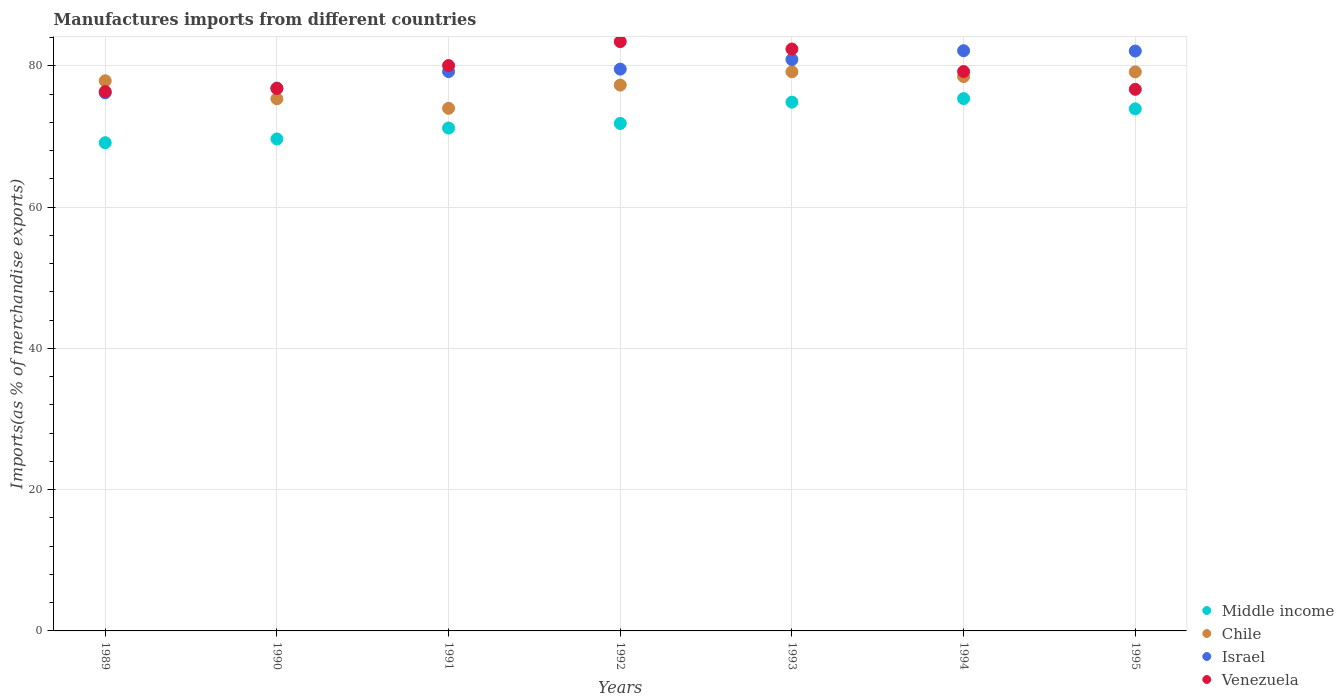How many different coloured dotlines are there?
Provide a succinct answer. 4. Is the number of dotlines equal to the number of legend labels?
Give a very brief answer. Yes. What is the percentage of imports to different countries in Israel in 1995?
Your answer should be compact. 82.09. Across all years, what is the maximum percentage of imports to different countries in Venezuela?
Offer a terse response. 83.42. Across all years, what is the minimum percentage of imports to different countries in Israel?
Your answer should be very brief. 76.18. In which year was the percentage of imports to different countries in Israel minimum?
Your response must be concise. 1989. What is the total percentage of imports to different countries in Chile in the graph?
Offer a terse response. 541.24. What is the difference between the percentage of imports to different countries in Chile in 1992 and that in 1995?
Your answer should be compact. -1.87. What is the difference between the percentage of imports to different countries in Israel in 1992 and the percentage of imports to different countries in Venezuela in 1994?
Your response must be concise. 0.34. What is the average percentage of imports to different countries in Middle income per year?
Make the answer very short. 72.27. In the year 1992, what is the difference between the percentage of imports to different countries in Middle income and percentage of imports to different countries in Venezuela?
Give a very brief answer. -11.58. What is the ratio of the percentage of imports to different countries in Middle income in 1990 to that in 1992?
Offer a terse response. 0.97. Is the percentage of imports to different countries in Israel in 1991 less than that in 1994?
Give a very brief answer. Yes. Is the difference between the percentage of imports to different countries in Middle income in 1993 and 1995 greater than the difference between the percentage of imports to different countries in Venezuela in 1993 and 1995?
Offer a very short reply. No. What is the difference between the highest and the second highest percentage of imports to different countries in Middle income?
Your answer should be very brief. 0.5. What is the difference between the highest and the lowest percentage of imports to different countries in Chile?
Offer a terse response. 5.17. Is it the case that in every year, the sum of the percentage of imports to different countries in Venezuela and percentage of imports to different countries in Israel  is greater than the percentage of imports to different countries in Chile?
Your answer should be compact. Yes. Does the percentage of imports to different countries in Venezuela monotonically increase over the years?
Make the answer very short. No. Is the percentage of imports to different countries in Israel strictly less than the percentage of imports to different countries in Chile over the years?
Ensure brevity in your answer.  No. How many years are there in the graph?
Offer a very short reply. 7. Does the graph contain any zero values?
Ensure brevity in your answer.  No. How are the legend labels stacked?
Your answer should be compact. Vertical. What is the title of the graph?
Your response must be concise. Manufactures imports from different countries. Does "Equatorial Guinea" appear as one of the legend labels in the graph?
Provide a succinct answer. No. What is the label or title of the X-axis?
Provide a succinct answer. Years. What is the label or title of the Y-axis?
Offer a very short reply. Imports(as % of merchandise exports). What is the Imports(as % of merchandise exports) of Middle income in 1989?
Your answer should be very brief. 69.11. What is the Imports(as % of merchandise exports) in Chile in 1989?
Offer a terse response. 77.88. What is the Imports(as % of merchandise exports) of Israel in 1989?
Ensure brevity in your answer.  76.18. What is the Imports(as % of merchandise exports) in Venezuela in 1989?
Keep it short and to the point. 76.35. What is the Imports(as % of merchandise exports) in Middle income in 1990?
Your answer should be very brief. 69.64. What is the Imports(as % of merchandise exports) of Chile in 1990?
Keep it short and to the point. 75.33. What is the Imports(as % of merchandise exports) in Israel in 1990?
Give a very brief answer. 76.84. What is the Imports(as % of merchandise exports) in Venezuela in 1990?
Give a very brief answer. 76.79. What is the Imports(as % of merchandise exports) of Middle income in 1991?
Give a very brief answer. 71.19. What is the Imports(as % of merchandise exports) in Chile in 1991?
Your answer should be very brief. 73.98. What is the Imports(as % of merchandise exports) in Israel in 1991?
Offer a very short reply. 79.18. What is the Imports(as % of merchandise exports) of Venezuela in 1991?
Your answer should be very brief. 80.03. What is the Imports(as % of merchandise exports) in Middle income in 1992?
Keep it short and to the point. 71.84. What is the Imports(as % of merchandise exports) of Chile in 1992?
Offer a terse response. 77.27. What is the Imports(as % of merchandise exports) of Israel in 1992?
Provide a short and direct response. 79.53. What is the Imports(as % of merchandise exports) of Venezuela in 1992?
Keep it short and to the point. 83.42. What is the Imports(as % of merchandise exports) of Middle income in 1993?
Offer a very short reply. 74.86. What is the Imports(as % of merchandise exports) of Chile in 1993?
Your answer should be very brief. 79.16. What is the Imports(as % of merchandise exports) in Israel in 1993?
Your answer should be very brief. 80.89. What is the Imports(as % of merchandise exports) in Venezuela in 1993?
Your answer should be compact. 82.38. What is the Imports(as % of merchandise exports) of Middle income in 1994?
Make the answer very short. 75.36. What is the Imports(as % of merchandise exports) of Chile in 1994?
Give a very brief answer. 78.48. What is the Imports(as % of merchandise exports) in Israel in 1994?
Make the answer very short. 82.14. What is the Imports(as % of merchandise exports) of Venezuela in 1994?
Make the answer very short. 79.19. What is the Imports(as % of merchandise exports) of Middle income in 1995?
Make the answer very short. 73.91. What is the Imports(as % of merchandise exports) in Chile in 1995?
Your response must be concise. 79.14. What is the Imports(as % of merchandise exports) of Israel in 1995?
Your answer should be very brief. 82.09. What is the Imports(as % of merchandise exports) in Venezuela in 1995?
Your response must be concise. 76.67. Across all years, what is the maximum Imports(as % of merchandise exports) in Middle income?
Make the answer very short. 75.36. Across all years, what is the maximum Imports(as % of merchandise exports) in Chile?
Make the answer very short. 79.16. Across all years, what is the maximum Imports(as % of merchandise exports) in Israel?
Offer a very short reply. 82.14. Across all years, what is the maximum Imports(as % of merchandise exports) in Venezuela?
Your answer should be very brief. 83.42. Across all years, what is the minimum Imports(as % of merchandise exports) of Middle income?
Provide a succinct answer. 69.11. Across all years, what is the minimum Imports(as % of merchandise exports) of Chile?
Your answer should be very brief. 73.98. Across all years, what is the minimum Imports(as % of merchandise exports) in Israel?
Offer a terse response. 76.18. Across all years, what is the minimum Imports(as % of merchandise exports) in Venezuela?
Offer a terse response. 76.35. What is the total Imports(as % of merchandise exports) in Middle income in the graph?
Keep it short and to the point. 505.9. What is the total Imports(as % of merchandise exports) of Chile in the graph?
Keep it short and to the point. 541.24. What is the total Imports(as % of merchandise exports) in Israel in the graph?
Offer a very short reply. 556.84. What is the total Imports(as % of merchandise exports) in Venezuela in the graph?
Keep it short and to the point. 554.83. What is the difference between the Imports(as % of merchandise exports) in Middle income in 1989 and that in 1990?
Ensure brevity in your answer.  -0.53. What is the difference between the Imports(as % of merchandise exports) of Chile in 1989 and that in 1990?
Provide a succinct answer. 2.54. What is the difference between the Imports(as % of merchandise exports) in Israel in 1989 and that in 1990?
Make the answer very short. -0.67. What is the difference between the Imports(as % of merchandise exports) of Venezuela in 1989 and that in 1990?
Provide a short and direct response. -0.44. What is the difference between the Imports(as % of merchandise exports) of Middle income in 1989 and that in 1991?
Give a very brief answer. -2.07. What is the difference between the Imports(as % of merchandise exports) of Chile in 1989 and that in 1991?
Make the answer very short. 3.89. What is the difference between the Imports(as % of merchandise exports) of Israel in 1989 and that in 1991?
Your answer should be compact. -3.01. What is the difference between the Imports(as % of merchandise exports) of Venezuela in 1989 and that in 1991?
Provide a succinct answer. -3.68. What is the difference between the Imports(as % of merchandise exports) of Middle income in 1989 and that in 1992?
Your answer should be compact. -2.73. What is the difference between the Imports(as % of merchandise exports) in Chile in 1989 and that in 1992?
Give a very brief answer. 0.61. What is the difference between the Imports(as % of merchandise exports) of Israel in 1989 and that in 1992?
Provide a short and direct response. -3.36. What is the difference between the Imports(as % of merchandise exports) of Venezuela in 1989 and that in 1992?
Make the answer very short. -7.07. What is the difference between the Imports(as % of merchandise exports) of Middle income in 1989 and that in 1993?
Your response must be concise. -5.75. What is the difference between the Imports(as % of merchandise exports) in Chile in 1989 and that in 1993?
Give a very brief answer. -1.28. What is the difference between the Imports(as % of merchandise exports) in Israel in 1989 and that in 1993?
Your answer should be compact. -4.71. What is the difference between the Imports(as % of merchandise exports) of Venezuela in 1989 and that in 1993?
Keep it short and to the point. -6.02. What is the difference between the Imports(as % of merchandise exports) in Middle income in 1989 and that in 1994?
Give a very brief answer. -6.25. What is the difference between the Imports(as % of merchandise exports) of Chile in 1989 and that in 1994?
Offer a terse response. -0.6. What is the difference between the Imports(as % of merchandise exports) of Israel in 1989 and that in 1994?
Your answer should be compact. -5.96. What is the difference between the Imports(as % of merchandise exports) in Venezuela in 1989 and that in 1994?
Make the answer very short. -2.84. What is the difference between the Imports(as % of merchandise exports) in Middle income in 1989 and that in 1995?
Keep it short and to the point. -4.8. What is the difference between the Imports(as % of merchandise exports) in Chile in 1989 and that in 1995?
Your answer should be very brief. -1.27. What is the difference between the Imports(as % of merchandise exports) of Israel in 1989 and that in 1995?
Offer a very short reply. -5.92. What is the difference between the Imports(as % of merchandise exports) of Venezuela in 1989 and that in 1995?
Your response must be concise. -0.32. What is the difference between the Imports(as % of merchandise exports) of Middle income in 1990 and that in 1991?
Make the answer very short. -1.54. What is the difference between the Imports(as % of merchandise exports) in Chile in 1990 and that in 1991?
Offer a very short reply. 1.35. What is the difference between the Imports(as % of merchandise exports) of Israel in 1990 and that in 1991?
Provide a short and direct response. -2.34. What is the difference between the Imports(as % of merchandise exports) in Venezuela in 1990 and that in 1991?
Make the answer very short. -3.24. What is the difference between the Imports(as % of merchandise exports) of Middle income in 1990 and that in 1992?
Your answer should be compact. -2.2. What is the difference between the Imports(as % of merchandise exports) in Chile in 1990 and that in 1992?
Offer a terse response. -1.94. What is the difference between the Imports(as % of merchandise exports) in Israel in 1990 and that in 1992?
Offer a very short reply. -2.69. What is the difference between the Imports(as % of merchandise exports) of Venezuela in 1990 and that in 1992?
Make the answer very short. -6.63. What is the difference between the Imports(as % of merchandise exports) of Middle income in 1990 and that in 1993?
Offer a very short reply. -5.21. What is the difference between the Imports(as % of merchandise exports) of Chile in 1990 and that in 1993?
Your response must be concise. -3.82. What is the difference between the Imports(as % of merchandise exports) of Israel in 1990 and that in 1993?
Offer a very short reply. -4.04. What is the difference between the Imports(as % of merchandise exports) of Venezuela in 1990 and that in 1993?
Ensure brevity in your answer.  -5.58. What is the difference between the Imports(as % of merchandise exports) of Middle income in 1990 and that in 1994?
Your answer should be compact. -5.71. What is the difference between the Imports(as % of merchandise exports) in Chile in 1990 and that in 1994?
Offer a terse response. -3.14. What is the difference between the Imports(as % of merchandise exports) in Israel in 1990 and that in 1994?
Your response must be concise. -5.29. What is the difference between the Imports(as % of merchandise exports) of Venezuela in 1990 and that in 1994?
Keep it short and to the point. -2.4. What is the difference between the Imports(as % of merchandise exports) of Middle income in 1990 and that in 1995?
Ensure brevity in your answer.  -4.26. What is the difference between the Imports(as % of merchandise exports) in Chile in 1990 and that in 1995?
Offer a very short reply. -3.81. What is the difference between the Imports(as % of merchandise exports) of Israel in 1990 and that in 1995?
Keep it short and to the point. -5.25. What is the difference between the Imports(as % of merchandise exports) in Venezuela in 1990 and that in 1995?
Keep it short and to the point. 0.12. What is the difference between the Imports(as % of merchandise exports) of Middle income in 1991 and that in 1992?
Your answer should be very brief. -0.65. What is the difference between the Imports(as % of merchandise exports) in Chile in 1991 and that in 1992?
Your answer should be compact. -3.29. What is the difference between the Imports(as % of merchandise exports) in Israel in 1991 and that in 1992?
Provide a succinct answer. -0.35. What is the difference between the Imports(as % of merchandise exports) in Venezuela in 1991 and that in 1992?
Your answer should be compact. -3.39. What is the difference between the Imports(as % of merchandise exports) in Middle income in 1991 and that in 1993?
Ensure brevity in your answer.  -3.67. What is the difference between the Imports(as % of merchandise exports) of Chile in 1991 and that in 1993?
Provide a short and direct response. -5.17. What is the difference between the Imports(as % of merchandise exports) in Israel in 1991 and that in 1993?
Your answer should be compact. -1.71. What is the difference between the Imports(as % of merchandise exports) of Venezuela in 1991 and that in 1993?
Your answer should be compact. -2.34. What is the difference between the Imports(as % of merchandise exports) in Middle income in 1991 and that in 1994?
Your response must be concise. -4.17. What is the difference between the Imports(as % of merchandise exports) of Chile in 1991 and that in 1994?
Your answer should be compact. -4.49. What is the difference between the Imports(as % of merchandise exports) in Israel in 1991 and that in 1994?
Give a very brief answer. -2.95. What is the difference between the Imports(as % of merchandise exports) of Venezuela in 1991 and that in 1994?
Keep it short and to the point. 0.84. What is the difference between the Imports(as % of merchandise exports) in Middle income in 1991 and that in 1995?
Offer a terse response. -2.72. What is the difference between the Imports(as % of merchandise exports) of Chile in 1991 and that in 1995?
Your answer should be compact. -5.16. What is the difference between the Imports(as % of merchandise exports) in Israel in 1991 and that in 1995?
Give a very brief answer. -2.91. What is the difference between the Imports(as % of merchandise exports) of Venezuela in 1991 and that in 1995?
Your response must be concise. 3.36. What is the difference between the Imports(as % of merchandise exports) in Middle income in 1992 and that in 1993?
Give a very brief answer. -3.02. What is the difference between the Imports(as % of merchandise exports) of Chile in 1992 and that in 1993?
Give a very brief answer. -1.88. What is the difference between the Imports(as % of merchandise exports) in Israel in 1992 and that in 1993?
Make the answer very short. -1.36. What is the difference between the Imports(as % of merchandise exports) of Venezuela in 1992 and that in 1993?
Provide a short and direct response. 1.05. What is the difference between the Imports(as % of merchandise exports) in Middle income in 1992 and that in 1994?
Your response must be concise. -3.52. What is the difference between the Imports(as % of merchandise exports) in Chile in 1992 and that in 1994?
Offer a very short reply. -1.21. What is the difference between the Imports(as % of merchandise exports) of Israel in 1992 and that in 1994?
Your answer should be very brief. -2.61. What is the difference between the Imports(as % of merchandise exports) of Venezuela in 1992 and that in 1994?
Provide a short and direct response. 4.23. What is the difference between the Imports(as % of merchandise exports) of Middle income in 1992 and that in 1995?
Make the answer very short. -2.07. What is the difference between the Imports(as % of merchandise exports) in Chile in 1992 and that in 1995?
Offer a terse response. -1.87. What is the difference between the Imports(as % of merchandise exports) in Israel in 1992 and that in 1995?
Provide a succinct answer. -2.56. What is the difference between the Imports(as % of merchandise exports) in Venezuela in 1992 and that in 1995?
Keep it short and to the point. 6.75. What is the difference between the Imports(as % of merchandise exports) of Middle income in 1993 and that in 1994?
Your answer should be compact. -0.5. What is the difference between the Imports(as % of merchandise exports) of Chile in 1993 and that in 1994?
Your answer should be very brief. 0.68. What is the difference between the Imports(as % of merchandise exports) of Israel in 1993 and that in 1994?
Ensure brevity in your answer.  -1.25. What is the difference between the Imports(as % of merchandise exports) in Venezuela in 1993 and that in 1994?
Ensure brevity in your answer.  3.19. What is the difference between the Imports(as % of merchandise exports) in Middle income in 1993 and that in 1995?
Keep it short and to the point. 0.95. What is the difference between the Imports(as % of merchandise exports) of Chile in 1993 and that in 1995?
Offer a terse response. 0.01. What is the difference between the Imports(as % of merchandise exports) in Israel in 1993 and that in 1995?
Make the answer very short. -1.2. What is the difference between the Imports(as % of merchandise exports) in Venezuela in 1993 and that in 1995?
Give a very brief answer. 5.71. What is the difference between the Imports(as % of merchandise exports) in Middle income in 1994 and that in 1995?
Your answer should be very brief. 1.45. What is the difference between the Imports(as % of merchandise exports) in Chile in 1994 and that in 1995?
Ensure brevity in your answer.  -0.67. What is the difference between the Imports(as % of merchandise exports) in Israel in 1994 and that in 1995?
Make the answer very short. 0.05. What is the difference between the Imports(as % of merchandise exports) of Venezuela in 1994 and that in 1995?
Keep it short and to the point. 2.52. What is the difference between the Imports(as % of merchandise exports) in Middle income in 1989 and the Imports(as % of merchandise exports) in Chile in 1990?
Provide a short and direct response. -6.22. What is the difference between the Imports(as % of merchandise exports) of Middle income in 1989 and the Imports(as % of merchandise exports) of Israel in 1990?
Your answer should be very brief. -7.73. What is the difference between the Imports(as % of merchandise exports) in Middle income in 1989 and the Imports(as % of merchandise exports) in Venezuela in 1990?
Keep it short and to the point. -7.68. What is the difference between the Imports(as % of merchandise exports) of Chile in 1989 and the Imports(as % of merchandise exports) of Israel in 1990?
Provide a short and direct response. 1.03. What is the difference between the Imports(as % of merchandise exports) in Chile in 1989 and the Imports(as % of merchandise exports) in Venezuela in 1990?
Provide a succinct answer. 1.09. What is the difference between the Imports(as % of merchandise exports) in Israel in 1989 and the Imports(as % of merchandise exports) in Venezuela in 1990?
Offer a very short reply. -0.62. What is the difference between the Imports(as % of merchandise exports) in Middle income in 1989 and the Imports(as % of merchandise exports) in Chile in 1991?
Offer a very short reply. -4.87. What is the difference between the Imports(as % of merchandise exports) of Middle income in 1989 and the Imports(as % of merchandise exports) of Israel in 1991?
Provide a succinct answer. -10.07. What is the difference between the Imports(as % of merchandise exports) of Middle income in 1989 and the Imports(as % of merchandise exports) of Venezuela in 1991?
Your answer should be very brief. -10.92. What is the difference between the Imports(as % of merchandise exports) in Chile in 1989 and the Imports(as % of merchandise exports) in Israel in 1991?
Give a very brief answer. -1.3. What is the difference between the Imports(as % of merchandise exports) of Chile in 1989 and the Imports(as % of merchandise exports) of Venezuela in 1991?
Ensure brevity in your answer.  -2.16. What is the difference between the Imports(as % of merchandise exports) of Israel in 1989 and the Imports(as % of merchandise exports) of Venezuela in 1991?
Your response must be concise. -3.86. What is the difference between the Imports(as % of merchandise exports) in Middle income in 1989 and the Imports(as % of merchandise exports) in Chile in 1992?
Provide a succinct answer. -8.16. What is the difference between the Imports(as % of merchandise exports) in Middle income in 1989 and the Imports(as % of merchandise exports) in Israel in 1992?
Ensure brevity in your answer.  -10.42. What is the difference between the Imports(as % of merchandise exports) of Middle income in 1989 and the Imports(as % of merchandise exports) of Venezuela in 1992?
Your response must be concise. -14.31. What is the difference between the Imports(as % of merchandise exports) in Chile in 1989 and the Imports(as % of merchandise exports) in Israel in 1992?
Offer a terse response. -1.65. What is the difference between the Imports(as % of merchandise exports) of Chile in 1989 and the Imports(as % of merchandise exports) of Venezuela in 1992?
Make the answer very short. -5.54. What is the difference between the Imports(as % of merchandise exports) in Israel in 1989 and the Imports(as % of merchandise exports) in Venezuela in 1992?
Provide a short and direct response. -7.25. What is the difference between the Imports(as % of merchandise exports) of Middle income in 1989 and the Imports(as % of merchandise exports) of Chile in 1993?
Your answer should be compact. -10.04. What is the difference between the Imports(as % of merchandise exports) in Middle income in 1989 and the Imports(as % of merchandise exports) in Israel in 1993?
Keep it short and to the point. -11.78. What is the difference between the Imports(as % of merchandise exports) of Middle income in 1989 and the Imports(as % of merchandise exports) of Venezuela in 1993?
Keep it short and to the point. -13.26. What is the difference between the Imports(as % of merchandise exports) of Chile in 1989 and the Imports(as % of merchandise exports) of Israel in 1993?
Keep it short and to the point. -3.01. What is the difference between the Imports(as % of merchandise exports) in Chile in 1989 and the Imports(as % of merchandise exports) in Venezuela in 1993?
Your answer should be very brief. -4.5. What is the difference between the Imports(as % of merchandise exports) of Israel in 1989 and the Imports(as % of merchandise exports) of Venezuela in 1993?
Your response must be concise. -6.2. What is the difference between the Imports(as % of merchandise exports) in Middle income in 1989 and the Imports(as % of merchandise exports) in Chile in 1994?
Keep it short and to the point. -9.37. What is the difference between the Imports(as % of merchandise exports) of Middle income in 1989 and the Imports(as % of merchandise exports) of Israel in 1994?
Provide a short and direct response. -13.03. What is the difference between the Imports(as % of merchandise exports) of Middle income in 1989 and the Imports(as % of merchandise exports) of Venezuela in 1994?
Provide a succinct answer. -10.08. What is the difference between the Imports(as % of merchandise exports) in Chile in 1989 and the Imports(as % of merchandise exports) in Israel in 1994?
Provide a short and direct response. -4.26. What is the difference between the Imports(as % of merchandise exports) of Chile in 1989 and the Imports(as % of merchandise exports) of Venezuela in 1994?
Offer a terse response. -1.31. What is the difference between the Imports(as % of merchandise exports) of Israel in 1989 and the Imports(as % of merchandise exports) of Venezuela in 1994?
Make the answer very short. -3.01. What is the difference between the Imports(as % of merchandise exports) in Middle income in 1989 and the Imports(as % of merchandise exports) in Chile in 1995?
Make the answer very short. -10.03. What is the difference between the Imports(as % of merchandise exports) in Middle income in 1989 and the Imports(as % of merchandise exports) in Israel in 1995?
Keep it short and to the point. -12.98. What is the difference between the Imports(as % of merchandise exports) in Middle income in 1989 and the Imports(as % of merchandise exports) in Venezuela in 1995?
Make the answer very short. -7.56. What is the difference between the Imports(as % of merchandise exports) of Chile in 1989 and the Imports(as % of merchandise exports) of Israel in 1995?
Make the answer very short. -4.21. What is the difference between the Imports(as % of merchandise exports) in Chile in 1989 and the Imports(as % of merchandise exports) in Venezuela in 1995?
Your answer should be compact. 1.21. What is the difference between the Imports(as % of merchandise exports) of Israel in 1989 and the Imports(as % of merchandise exports) of Venezuela in 1995?
Your response must be concise. -0.49. What is the difference between the Imports(as % of merchandise exports) in Middle income in 1990 and the Imports(as % of merchandise exports) in Chile in 1991?
Keep it short and to the point. -4.34. What is the difference between the Imports(as % of merchandise exports) of Middle income in 1990 and the Imports(as % of merchandise exports) of Israel in 1991?
Provide a succinct answer. -9.54. What is the difference between the Imports(as % of merchandise exports) in Middle income in 1990 and the Imports(as % of merchandise exports) in Venezuela in 1991?
Make the answer very short. -10.39. What is the difference between the Imports(as % of merchandise exports) of Chile in 1990 and the Imports(as % of merchandise exports) of Israel in 1991?
Offer a terse response. -3.85. What is the difference between the Imports(as % of merchandise exports) in Chile in 1990 and the Imports(as % of merchandise exports) in Venezuela in 1991?
Make the answer very short. -4.7. What is the difference between the Imports(as % of merchandise exports) in Israel in 1990 and the Imports(as % of merchandise exports) in Venezuela in 1991?
Your answer should be very brief. -3.19. What is the difference between the Imports(as % of merchandise exports) of Middle income in 1990 and the Imports(as % of merchandise exports) of Chile in 1992?
Offer a terse response. -7.63. What is the difference between the Imports(as % of merchandise exports) of Middle income in 1990 and the Imports(as % of merchandise exports) of Israel in 1992?
Your answer should be compact. -9.89. What is the difference between the Imports(as % of merchandise exports) in Middle income in 1990 and the Imports(as % of merchandise exports) in Venezuela in 1992?
Provide a short and direct response. -13.78. What is the difference between the Imports(as % of merchandise exports) in Chile in 1990 and the Imports(as % of merchandise exports) in Israel in 1992?
Your answer should be compact. -4.2. What is the difference between the Imports(as % of merchandise exports) in Chile in 1990 and the Imports(as % of merchandise exports) in Venezuela in 1992?
Keep it short and to the point. -8.09. What is the difference between the Imports(as % of merchandise exports) of Israel in 1990 and the Imports(as % of merchandise exports) of Venezuela in 1992?
Provide a succinct answer. -6.58. What is the difference between the Imports(as % of merchandise exports) of Middle income in 1990 and the Imports(as % of merchandise exports) of Chile in 1993?
Keep it short and to the point. -9.51. What is the difference between the Imports(as % of merchandise exports) in Middle income in 1990 and the Imports(as % of merchandise exports) in Israel in 1993?
Your answer should be very brief. -11.24. What is the difference between the Imports(as % of merchandise exports) of Middle income in 1990 and the Imports(as % of merchandise exports) of Venezuela in 1993?
Your answer should be very brief. -12.73. What is the difference between the Imports(as % of merchandise exports) of Chile in 1990 and the Imports(as % of merchandise exports) of Israel in 1993?
Your answer should be very brief. -5.55. What is the difference between the Imports(as % of merchandise exports) of Chile in 1990 and the Imports(as % of merchandise exports) of Venezuela in 1993?
Ensure brevity in your answer.  -7.04. What is the difference between the Imports(as % of merchandise exports) in Israel in 1990 and the Imports(as % of merchandise exports) in Venezuela in 1993?
Your answer should be compact. -5.53. What is the difference between the Imports(as % of merchandise exports) of Middle income in 1990 and the Imports(as % of merchandise exports) of Chile in 1994?
Provide a short and direct response. -8.83. What is the difference between the Imports(as % of merchandise exports) of Middle income in 1990 and the Imports(as % of merchandise exports) of Israel in 1994?
Provide a short and direct response. -12.49. What is the difference between the Imports(as % of merchandise exports) in Middle income in 1990 and the Imports(as % of merchandise exports) in Venezuela in 1994?
Provide a short and direct response. -9.55. What is the difference between the Imports(as % of merchandise exports) in Chile in 1990 and the Imports(as % of merchandise exports) in Israel in 1994?
Ensure brevity in your answer.  -6.8. What is the difference between the Imports(as % of merchandise exports) in Chile in 1990 and the Imports(as % of merchandise exports) in Venezuela in 1994?
Make the answer very short. -3.86. What is the difference between the Imports(as % of merchandise exports) in Israel in 1990 and the Imports(as % of merchandise exports) in Venezuela in 1994?
Provide a short and direct response. -2.35. What is the difference between the Imports(as % of merchandise exports) of Middle income in 1990 and the Imports(as % of merchandise exports) of Chile in 1995?
Provide a succinct answer. -9.5. What is the difference between the Imports(as % of merchandise exports) of Middle income in 1990 and the Imports(as % of merchandise exports) of Israel in 1995?
Keep it short and to the point. -12.45. What is the difference between the Imports(as % of merchandise exports) in Middle income in 1990 and the Imports(as % of merchandise exports) in Venezuela in 1995?
Your response must be concise. -7.03. What is the difference between the Imports(as % of merchandise exports) of Chile in 1990 and the Imports(as % of merchandise exports) of Israel in 1995?
Give a very brief answer. -6.76. What is the difference between the Imports(as % of merchandise exports) in Chile in 1990 and the Imports(as % of merchandise exports) in Venezuela in 1995?
Offer a terse response. -1.34. What is the difference between the Imports(as % of merchandise exports) in Israel in 1990 and the Imports(as % of merchandise exports) in Venezuela in 1995?
Offer a terse response. 0.17. What is the difference between the Imports(as % of merchandise exports) in Middle income in 1991 and the Imports(as % of merchandise exports) in Chile in 1992?
Provide a succinct answer. -6.09. What is the difference between the Imports(as % of merchandise exports) of Middle income in 1991 and the Imports(as % of merchandise exports) of Israel in 1992?
Offer a very short reply. -8.34. What is the difference between the Imports(as % of merchandise exports) of Middle income in 1991 and the Imports(as % of merchandise exports) of Venezuela in 1992?
Provide a short and direct response. -12.24. What is the difference between the Imports(as % of merchandise exports) of Chile in 1991 and the Imports(as % of merchandise exports) of Israel in 1992?
Make the answer very short. -5.55. What is the difference between the Imports(as % of merchandise exports) of Chile in 1991 and the Imports(as % of merchandise exports) of Venezuela in 1992?
Offer a terse response. -9.44. What is the difference between the Imports(as % of merchandise exports) in Israel in 1991 and the Imports(as % of merchandise exports) in Venezuela in 1992?
Offer a very short reply. -4.24. What is the difference between the Imports(as % of merchandise exports) of Middle income in 1991 and the Imports(as % of merchandise exports) of Chile in 1993?
Your answer should be very brief. -7.97. What is the difference between the Imports(as % of merchandise exports) of Middle income in 1991 and the Imports(as % of merchandise exports) of Israel in 1993?
Your response must be concise. -9.7. What is the difference between the Imports(as % of merchandise exports) in Middle income in 1991 and the Imports(as % of merchandise exports) in Venezuela in 1993?
Offer a terse response. -11.19. What is the difference between the Imports(as % of merchandise exports) in Chile in 1991 and the Imports(as % of merchandise exports) in Israel in 1993?
Offer a terse response. -6.9. What is the difference between the Imports(as % of merchandise exports) of Chile in 1991 and the Imports(as % of merchandise exports) of Venezuela in 1993?
Offer a very short reply. -8.39. What is the difference between the Imports(as % of merchandise exports) in Israel in 1991 and the Imports(as % of merchandise exports) in Venezuela in 1993?
Give a very brief answer. -3.19. What is the difference between the Imports(as % of merchandise exports) in Middle income in 1991 and the Imports(as % of merchandise exports) in Chile in 1994?
Your response must be concise. -7.29. What is the difference between the Imports(as % of merchandise exports) in Middle income in 1991 and the Imports(as % of merchandise exports) in Israel in 1994?
Your response must be concise. -10.95. What is the difference between the Imports(as % of merchandise exports) in Middle income in 1991 and the Imports(as % of merchandise exports) in Venezuela in 1994?
Give a very brief answer. -8. What is the difference between the Imports(as % of merchandise exports) in Chile in 1991 and the Imports(as % of merchandise exports) in Israel in 1994?
Your response must be concise. -8.15. What is the difference between the Imports(as % of merchandise exports) in Chile in 1991 and the Imports(as % of merchandise exports) in Venezuela in 1994?
Offer a very short reply. -5.21. What is the difference between the Imports(as % of merchandise exports) of Israel in 1991 and the Imports(as % of merchandise exports) of Venezuela in 1994?
Your answer should be very brief. -0.01. What is the difference between the Imports(as % of merchandise exports) in Middle income in 1991 and the Imports(as % of merchandise exports) in Chile in 1995?
Ensure brevity in your answer.  -7.96. What is the difference between the Imports(as % of merchandise exports) in Middle income in 1991 and the Imports(as % of merchandise exports) in Israel in 1995?
Offer a terse response. -10.9. What is the difference between the Imports(as % of merchandise exports) in Middle income in 1991 and the Imports(as % of merchandise exports) in Venezuela in 1995?
Your answer should be compact. -5.48. What is the difference between the Imports(as % of merchandise exports) of Chile in 1991 and the Imports(as % of merchandise exports) of Israel in 1995?
Give a very brief answer. -8.11. What is the difference between the Imports(as % of merchandise exports) in Chile in 1991 and the Imports(as % of merchandise exports) in Venezuela in 1995?
Make the answer very short. -2.69. What is the difference between the Imports(as % of merchandise exports) of Israel in 1991 and the Imports(as % of merchandise exports) of Venezuela in 1995?
Your answer should be compact. 2.51. What is the difference between the Imports(as % of merchandise exports) of Middle income in 1992 and the Imports(as % of merchandise exports) of Chile in 1993?
Your answer should be very brief. -7.32. What is the difference between the Imports(as % of merchandise exports) in Middle income in 1992 and the Imports(as % of merchandise exports) in Israel in 1993?
Your answer should be compact. -9.05. What is the difference between the Imports(as % of merchandise exports) in Middle income in 1992 and the Imports(as % of merchandise exports) in Venezuela in 1993?
Your answer should be very brief. -10.54. What is the difference between the Imports(as % of merchandise exports) of Chile in 1992 and the Imports(as % of merchandise exports) of Israel in 1993?
Give a very brief answer. -3.61. What is the difference between the Imports(as % of merchandise exports) in Chile in 1992 and the Imports(as % of merchandise exports) in Venezuela in 1993?
Keep it short and to the point. -5.1. What is the difference between the Imports(as % of merchandise exports) of Israel in 1992 and the Imports(as % of merchandise exports) of Venezuela in 1993?
Keep it short and to the point. -2.84. What is the difference between the Imports(as % of merchandise exports) of Middle income in 1992 and the Imports(as % of merchandise exports) of Chile in 1994?
Offer a terse response. -6.64. What is the difference between the Imports(as % of merchandise exports) in Middle income in 1992 and the Imports(as % of merchandise exports) in Israel in 1994?
Give a very brief answer. -10.3. What is the difference between the Imports(as % of merchandise exports) of Middle income in 1992 and the Imports(as % of merchandise exports) of Venezuela in 1994?
Your answer should be compact. -7.35. What is the difference between the Imports(as % of merchandise exports) in Chile in 1992 and the Imports(as % of merchandise exports) in Israel in 1994?
Your response must be concise. -4.86. What is the difference between the Imports(as % of merchandise exports) of Chile in 1992 and the Imports(as % of merchandise exports) of Venezuela in 1994?
Give a very brief answer. -1.92. What is the difference between the Imports(as % of merchandise exports) in Israel in 1992 and the Imports(as % of merchandise exports) in Venezuela in 1994?
Give a very brief answer. 0.34. What is the difference between the Imports(as % of merchandise exports) in Middle income in 1992 and the Imports(as % of merchandise exports) in Chile in 1995?
Make the answer very short. -7.3. What is the difference between the Imports(as % of merchandise exports) in Middle income in 1992 and the Imports(as % of merchandise exports) in Israel in 1995?
Give a very brief answer. -10.25. What is the difference between the Imports(as % of merchandise exports) of Middle income in 1992 and the Imports(as % of merchandise exports) of Venezuela in 1995?
Make the answer very short. -4.83. What is the difference between the Imports(as % of merchandise exports) in Chile in 1992 and the Imports(as % of merchandise exports) in Israel in 1995?
Provide a short and direct response. -4.82. What is the difference between the Imports(as % of merchandise exports) in Chile in 1992 and the Imports(as % of merchandise exports) in Venezuela in 1995?
Make the answer very short. 0.6. What is the difference between the Imports(as % of merchandise exports) in Israel in 1992 and the Imports(as % of merchandise exports) in Venezuela in 1995?
Provide a succinct answer. 2.86. What is the difference between the Imports(as % of merchandise exports) of Middle income in 1993 and the Imports(as % of merchandise exports) of Chile in 1994?
Your response must be concise. -3.62. What is the difference between the Imports(as % of merchandise exports) in Middle income in 1993 and the Imports(as % of merchandise exports) in Israel in 1994?
Provide a short and direct response. -7.28. What is the difference between the Imports(as % of merchandise exports) in Middle income in 1993 and the Imports(as % of merchandise exports) in Venezuela in 1994?
Your response must be concise. -4.33. What is the difference between the Imports(as % of merchandise exports) of Chile in 1993 and the Imports(as % of merchandise exports) of Israel in 1994?
Give a very brief answer. -2.98. What is the difference between the Imports(as % of merchandise exports) in Chile in 1993 and the Imports(as % of merchandise exports) in Venezuela in 1994?
Offer a terse response. -0.03. What is the difference between the Imports(as % of merchandise exports) in Israel in 1993 and the Imports(as % of merchandise exports) in Venezuela in 1994?
Your answer should be compact. 1.7. What is the difference between the Imports(as % of merchandise exports) of Middle income in 1993 and the Imports(as % of merchandise exports) of Chile in 1995?
Your answer should be very brief. -4.29. What is the difference between the Imports(as % of merchandise exports) in Middle income in 1993 and the Imports(as % of merchandise exports) in Israel in 1995?
Offer a very short reply. -7.23. What is the difference between the Imports(as % of merchandise exports) of Middle income in 1993 and the Imports(as % of merchandise exports) of Venezuela in 1995?
Keep it short and to the point. -1.81. What is the difference between the Imports(as % of merchandise exports) in Chile in 1993 and the Imports(as % of merchandise exports) in Israel in 1995?
Offer a very short reply. -2.94. What is the difference between the Imports(as % of merchandise exports) in Chile in 1993 and the Imports(as % of merchandise exports) in Venezuela in 1995?
Provide a short and direct response. 2.49. What is the difference between the Imports(as % of merchandise exports) in Israel in 1993 and the Imports(as % of merchandise exports) in Venezuela in 1995?
Keep it short and to the point. 4.22. What is the difference between the Imports(as % of merchandise exports) of Middle income in 1994 and the Imports(as % of merchandise exports) of Chile in 1995?
Your response must be concise. -3.79. What is the difference between the Imports(as % of merchandise exports) in Middle income in 1994 and the Imports(as % of merchandise exports) in Israel in 1995?
Offer a very short reply. -6.73. What is the difference between the Imports(as % of merchandise exports) in Middle income in 1994 and the Imports(as % of merchandise exports) in Venezuela in 1995?
Ensure brevity in your answer.  -1.31. What is the difference between the Imports(as % of merchandise exports) in Chile in 1994 and the Imports(as % of merchandise exports) in Israel in 1995?
Provide a short and direct response. -3.61. What is the difference between the Imports(as % of merchandise exports) in Chile in 1994 and the Imports(as % of merchandise exports) in Venezuela in 1995?
Ensure brevity in your answer.  1.81. What is the difference between the Imports(as % of merchandise exports) of Israel in 1994 and the Imports(as % of merchandise exports) of Venezuela in 1995?
Give a very brief answer. 5.47. What is the average Imports(as % of merchandise exports) of Middle income per year?
Provide a succinct answer. 72.27. What is the average Imports(as % of merchandise exports) of Chile per year?
Keep it short and to the point. 77.32. What is the average Imports(as % of merchandise exports) of Israel per year?
Offer a terse response. 79.55. What is the average Imports(as % of merchandise exports) in Venezuela per year?
Your answer should be compact. 79.26. In the year 1989, what is the difference between the Imports(as % of merchandise exports) of Middle income and Imports(as % of merchandise exports) of Chile?
Your answer should be very brief. -8.77. In the year 1989, what is the difference between the Imports(as % of merchandise exports) of Middle income and Imports(as % of merchandise exports) of Israel?
Your response must be concise. -7.06. In the year 1989, what is the difference between the Imports(as % of merchandise exports) of Middle income and Imports(as % of merchandise exports) of Venezuela?
Offer a very short reply. -7.24. In the year 1989, what is the difference between the Imports(as % of merchandise exports) in Chile and Imports(as % of merchandise exports) in Israel?
Offer a very short reply. 1.7. In the year 1989, what is the difference between the Imports(as % of merchandise exports) of Chile and Imports(as % of merchandise exports) of Venezuela?
Provide a succinct answer. 1.52. In the year 1989, what is the difference between the Imports(as % of merchandise exports) of Israel and Imports(as % of merchandise exports) of Venezuela?
Make the answer very short. -0.18. In the year 1990, what is the difference between the Imports(as % of merchandise exports) of Middle income and Imports(as % of merchandise exports) of Chile?
Keep it short and to the point. -5.69. In the year 1990, what is the difference between the Imports(as % of merchandise exports) of Middle income and Imports(as % of merchandise exports) of Israel?
Give a very brief answer. -7.2. In the year 1990, what is the difference between the Imports(as % of merchandise exports) of Middle income and Imports(as % of merchandise exports) of Venezuela?
Your answer should be compact. -7.15. In the year 1990, what is the difference between the Imports(as % of merchandise exports) of Chile and Imports(as % of merchandise exports) of Israel?
Offer a terse response. -1.51. In the year 1990, what is the difference between the Imports(as % of merchandise exports) of Chile and Imports(as % of merchandise exports) of Venezuela?
Your answer should be compact. -1.46. In the year 1990, what is the difference between the Imports(as % of merchandise exports) of Israel and Imports(as % of merchandise exports) of Venezuela?
Offer a very short reply. 0.05. In the year 1991, what is the difference between the Imports(as % of merchandise exports) in Middle income and Imports(as % of merchandise exports) in Chile?
Your answer should be compact. -2.8. In the year 1991, what is the difference between the Imports(as % of merchandise exports) of Middle income and Imports(as % of merchandise exports) of Israel?
Offer a very short reply. -8. In the year 1991, what is the difference between the Imports(as % of merchandise exports) in Middle income and Imports(as % of merchandise exports) in Venezuela?
Offer a terse response. -8.85. In the year 1991, what is the difference between the Imports(as % of merchandise exports) in Chile and Imports(as % of merchandise exports) in Israel?
Give a very brief answer. -5.2. In the year 1991, what is the difference between the Imports(as % of merchandise exports) in Chile and Imports(as % of merchandise exports) in Venezuela?
Keep it short and to the point. -6.05. In the year 1991, what is the difference between the Imports(as % of merchandise exports) in Israel and Imports(as % of merchandise exports) in Venezuela?
Ensure brevity in your answer.  -0.85. In the year 1992, what is the difference between the Imports(as % of merchandise exports) of Middle income and Imports(as % of merchandise exports) of Chile?
Provide a short and direct response. -5.43. In the year 1992, what is the difference between the Imports(as % of merchandise exports) of Middle income and Imports(as % of merchandise exports) of Israel?
Provide a short and direct response. -7.69. In the year 1992, what is the difference between the Imports(as % of merchandise exports) of Middle income and Imports(as % of merchandise exports) of Venezuela?
Provide a short and direct response. -11.58. In the year 1992, what is the difference between the Imports(as % of merchandise exports) in Chile and Imports(as % of merchandise exports) in Israel?
Keep it short and to the point. -2.26. In the year 1992, what is the difference between the Imports(as % of merchandise exports) in Chile and Imports(as % of merchandise exports) in Venezuela?
Keep it short and to the point. -6.15. In the year 1992, what is the difference between the Imports(as % of merchandise exports) of Israel and Imports(as % of merchandise exports) of Venezuela?
Offer a terse response. -3.89. In the year 1993, what is the difference between the Imports(as % of merchandise exports) in Middle income and Imports(as % of merchandise exports) in Chile?
Offer a very short reply. -4.3. In the year 1993, what is the difference between the Imports(as % of merchandise exports) of Middle income and Imports(as % of merchandise exports) of Israel?
Your answer should be very brief. -6.03. In the year 1993, what is the difference between the Imports(as % of merchandise exports) of Middle income and Imports(as % of merchandise exports) of Venezuela?
Keep it short and to the point. -7.52. In the year 1993, what is the difference between the Imports(as % of merchandise exports) of Chile and Imports(as % of merchandise exports) of Israel?
Offer a very short reply. -1.73. In the year 1993, what is the difference between the Imports(as % of merchandise exports) in Chile and Imports(as % of merchandise exports) in Venezuela?
Your answer should be compact. -3.22. In the year 1993, what is the difference between the Imports(as % of merchandise exports) of Israel and Imports(as % of merchandise exports) of Venezuela?
Provide a short and direct response. -1.49. In the year 1994, what is the difference between the Imports(as % of merchandise exports) of Middle income and Imports(as % of merchandise exports) of Chile?
Provide a succinct answer. -3.12. In the year 1994, what is the difference between the Imports(as % of merchandise exports) in Middle income and Imports(as % of merchandise exports) in Israel?
Make the answer very short. -6.78. In the year 1994, what is the difference between the Imports(as % of merchandise exports) in Middle income and Imports(as % of merchandise exports) in Venezuela?
Keep it short and to the point. -3.83. In the year 1994, what is the difference between the Imports(as % of merchandise exports) of Chile and Imports(as % of merchandise exports) of Israel?
Offer a terse response. -3.66. In the year 1994, what is the difference between the Imports(as % of merchandise exports) of Chile and Imports(as % of merchandise exports) of Venezuela?
Provide a short and direct response. -0.71. In the year 1994, what is the difference between the Imports(as % of merchandise exports) in Israel and Imports(as % of merchandise exports) in Venezuela?
Your answer should be very brief. 2.95. In the year 1995, what is the difference between the Imports(as % of merchandise exports) in Middle income and Imports(as % of merchandise exports) in Chile?
Offer a terse response. -5.24. In the year 1995, what is the difference between the Imports(as % of merchandise exports) in Middle income and Imports(as % of merchandise exports) in Israel?
Provide a succinct answer. -8.18. In the year 1995, what is the difference between the Imports(as % of merchandise exports) of Middle income and Imports(as % of merchandise exports) of Venezuela?
Make the answer very short. -2.76. In the year 1995, what is the difference between the Imports(as % of merchandise exports) in Chile and Imports(as % of merchandise exports) in Israel?
Your response must be concise. -2.95. In the year 1995, what is the difference between the Imports(as % of merchandise exports) in Chile and Imports(as % of merchandise exports) in Venezuela?
Provide a succinct answer. 2.47. In the year 1995, what is the difference between the Imports(as % of merchandise exports) in Israel and Imports(as % of merchandise exports) in Venezuela?
Offer a very short reply. 5.42. What is the ratio of the Imports(as % of merchandise exports) in Chile in 1989 to that in 1990?
Provide a succinct answer. 1.03. What is the ratio of the Imports(as % of merchandise exports) in Israel in 1989 to that in 1990?
Offer a terse response. 0.99. What is the ratio of the Imports(as % of merchandise exports) in Middle income in 1989 to that in 1991?
Make the answer very short. 0.97. What is the ratio of the Imports(as % of merchandise exports) of Chile in 1989 to that in 1991?
Provide a short and direct response. 1.05. What is the ratio of the Imports(as % of merchandise exports) in Venezuela in 1989 to that in 1991?
Your answer should be very brief. 0.95. What is the ratio of the Imports(as % of merchandise exports) of Israel in 1989 to that in 1992?
Make the answer very short. 0.96. What is the ratio of the Imports(as % of merchandise exports) in Venezuela in 1989 to that in 1992?
Your answer should be very brief. 0.92. What is the ratio of the Imports(as % of merchandise exports) in Middle income in 1989 to that in 1993?
Ensure brevity in your answer.  0.92. What is the ratio of the Imports(as % of merchandise exports) in Chile in 1989 to that in 1993?
Keep it short and to the point. 0.98. What is the ratio of the Imports(as % of merchandise exports) of Israel in 1989 to that in 1993?
Provide a succinct answer. 0.94. What is the ratio of the Imports(as % of merchandise exports) of Venezuela in 1989 to that in 1993?
Offer a very short reply. 0.93. What is the ratio of the Imports(as % of merchandise exports) of Middle income in 1989 to that in 1994?
Offer a terse response. 0.92. What is the ratio of the Imports(as % of merchandise exports) of Chile in 1989 to that in 1994?
Your response must be concise. 0.99. What is the ratio of the Imports(as % of merchandise exports) of Israel in 1989 to that in 1994?
Keep it short and to the point. 0.93. What is the ratio of the Imports(as % of merchandise exports) of Venezuela in 1989 to that in 1994?
Your answer should be very brief. 0.96. What is the ratio of the Imports(as % of merchandise exports) in Middle income in 1989 to that in 1995?
Offer a terse response. 0.94. What is the ratio of the Imports(as % of merchandise exports) of Chile in 1989 to that in 1995?
Offer a terse response. 0.98. What is the ratio of the Imports(as % of merchandise exports) of Israel in 1989 to that in 1995?
Your response must be concise. 0.93. What is the ratio of the Imports(as % of merchandise exports) of Middle income in 1990 to that in 1991?
Your answer should be very brief. 0.98. What is the ratio of the Imports(as % of merchandise exports) of Chile in 1990 to that in 1991?
Your response must be concise. 1.02. What is the ratio of the Imports(as % of merchandise exports) of Israel in 1990 to that in 1991?
Provide a short and direct response. 0.97. What is the ratio of the Imports(as % of merchandise exports) in Venezuela in 1990 to that in 1991?
Offer a terse response. 0.96. What is the ratio of the Imports(as % of merchandise exports) in Middle income in 1990 to that in 1992?
Provide a succinct answer. 0.97. What is the ratio of the Imports(as % of merchandise exports) of Chile in 1990 to that in 1992?
Ensure brevity in your answer.  0.97. What is the ratio of the Imports(as % of merchandise exports) in Israel in 1990 to that in 1992?
Your answer should be compact. 0.97. What is the ratio of the Imports(as % of merchandise exports) in Venezuela in 1990 to that in 1992?
Your answer should be very brief. 0.92. What is the ratio of the Imports(as % of merchandise exports) in Middle income in 1990 to that in 1993?
Offer a very short reply. 0.93. What is the ratio of the Imports(as % of merchandise exports) of Chile in 1990 to that in 1993?
Make the answer very short. 0.95. What is the ratio of the Imports(as % of merchandise exports) of Israel in 1990 to that in 1993?
Make the answer very short. 0.95. What is the ratio of the Imports(as % of merchandise exports) of Venezuela in 1990 to that in 1993?
Ensure brevity in your answer.  0.93. What is the ratio of the Imports(as % of merchandise exports) in Middle income in 1990 to that in 1994?
Your answer should be compact. 0.92. What is the ratio of the Imports(as % of merchandise exports) in Chile in 1990 to that in 1994?
Give a very brief answer. 0.96. What is the ratio of the Imports(as % of merchandise exports) in Israel in 1990 to that in 1994?
Give a very brief answer. 0.94. What is the ratio of the Imports(as % of merchandise exports) in Venezuela in 1990 to that in 1994?
Make the answer very short. 0.97. What is the ratio of the Imports(as % of merchandise exports) in Middle income in 1990 to that in 1995?
Ensure brevity in your answer.  0.94. What is the ratio of the Imports(as % of merchandise exports) in Chile in 1990 to that in 1995?
Offer a very short reply. 0.95. What is the ratio of the Imports(as % of merchandise exports) of Israel in 1990 to that in 1995?
Make the answer very short. 0.94. What is the ratio of the Imports(as % of merchandise exports) in Venezuela in 1990 to that in 1995?
Your answer should be compact. 1. What is the ratio of the Imports(as % of merchandise exports) in Middle income in 1991 to that in 1992?
Your answer should be very brief. 0.99. What is the ratio of the Imports(as % of merchandise exports) in Chile in 1991 to that in 1992?
Make the answer very short. 0.96. What is the ratio of the Imports(as % of merchandise exports) of Venezuela in 1991 to that in 1992?
Provide a succinct answer. 0.96. What is the ratio of the Imports(as % of merchandise exports) of Middle income in 1991 to that in 1993?
Offer a terse response. 0.95. What is the ratio of the Imports(as % of merchandise exports) of Chile in 1991 to that in 1993?
Keep it short and to the point. 0.93. What is the ratio of the Imports(as % of merchandise exports) in Israel in 1991 to that in 1993?
Offer a very short reply. 0.98. What is the ratio of the Imports(as % of merchandise exports) in Venezuela in 1991 to that in 1993?
Give a very brief answer. 0.97. What is the ratio of the Imports(as % of merchandise exports) in Middle income in 1991 to that in 1994?
Provide a short and direct response. 0.94. What is the ratio of the Imports(as % of merchandise exports) in Chile in 1991 to that in 1994?
Provide a succinct answer. 0.94. What is the ratio of the Imports(as % of merchandise exports) of Israel in 1991 to that in 1994?
Your answer should be compact. 0.96. What is the ratio of the Imports(as % of merchandise exports) of Venezuela in 1991 to that in 1994?
Your answer should be compact. 1.01. What is the ratio of the Imports(as % of merchandise exports) in Middle income in 1991 to that in 1995?
Your answer should be compact. 0.96. What is the ratio of the Imports(as % of merchandise exports) in Chile in 1991 to that in 1995?
Offer a very short reply. 0.93. What is the ratio of the Imports(as % of merchandise exports) of Israel in 1991 to that in 1995?
Ensure brevity in your answer.  0.96. What is the ratio of the Imports(as % of merchandise exports) in Venezuela in 1991 to that in 1995?
Offer a terse response. 1.04. What is the ratio of the Imports(as % of merchandise exports) of Middle income in 1992 to that in 1993?
Provide a short and direct response. 0.96. What is the ratio of the Imports(as % of merchandise exports) of Chile in 1992 to that in 1993?
Offer a very short reply. 0.98. What is the ratio of the Imports(as % of merchandise exports) of Israel in 1992 to that in 1993?
Provide a succinct answer. 0.98. What is the ratio of the Imports(as % of merchandise exports) in Venezuela in 1992 to that in 1993?
Provide a short and direct response. 1.01. What is the ratio of the Imports(as % of merchandise exports) of Middle income in 1992 to that in 1994?
Provide a short and direct response. 0.95. What is the ratio of the Imports(as % of merchandise exports) in Chile in 1992 to that in 1994?
Offer a very short reply. 0.98. What is the ratio of the Imports(as % of merchandise exports) in Israel in 1992 to that in 1994?
Offer a very short reply. 0.97. What is the ratio of the Imports(as % of merchandise exports) in Venezuela in 1992 to that in 1994?
Your response must be concise. 1.05. What is the ratio of the Imports(as % of merchandise exports) of Middle income in 1992 to that in 1995?
Your answer should be very brief. 0.97. What is the ratio of the Imports(as % of merchandise exports) of Chile in 1992 to that in 1995?
Keep it short and to the point. 0.98. What is the ratio of the Imports(as % of merchandise exports) in Israel in 1992 to that in 1995?
Offer a very short reply. 0.97. What is the ratio of the Imports(as % of merchandise exports) in Venezuela in 1992 to that in 1995?
Offer a very short reply. 1.09. What is the ratio of the Imports(as % of merchandise exports) in Chile in 1993 to that in 1994?
Keep it short and to the point. 1.01. What is the ratio of the Imports(as % of merchandise exports) of Israel in 1993 to that in 1994?
Provide a short and direct response. 0.98. What is the ratio of the Imports(as % of merchandise exports) of Venezuela in 1993 to that in 1994?
Provide a succinct answer. 1.04. What is the ratio of the Imports(as % of merchandise exports) of Middle income in 1993 to that in 1995?
Your response must be concise. 1.01. What is the ratio of the Imports(as % of merchandise exports) in Chile in 1993 to that in 1995?
Give a very brief answer. 1. What is the ratio of the Imports(as % of merchandise exports) of Venezuela in 1993 to that in 1995?
Make the answer very short. 1.07. What is the ratio of the Imports(as % of merchandise exports) in Middle income in 1994 to that in 1995?
Keep it short and to the point. 1.02. What is the ratio of the Imports(as % of merchandise exports) in Chile in 1994 to that in 1995?
Make the answer very short. 0.99. What is the ratio of the Imports(as % of merchandise exports) in Israel in 1994 to that in 1995?
Provide a short and direct response. 1. What is the ratio of the Imports(as % of merchandise exports) in Venezuela in 1994 to that in 1995?
Your answer should be very brief. 1.03. What is the difference between the highest and the second highest Imports(as % of merchandise exports) of Middle income?
Give a very brief answer. 0.5. What is the difference between the highest and the second highest Imports(as % of merchandise exports) in Chile?
Your response must be concise. 0.01. What is the difference between the highest and the second highest Imports(as % of merchandise exports) of Israel?
Your answer should be compact. 0.05. What is the difference between the highest and the second highest Imports(as % of merchandise exports) in Venezuela?
Your answer should be very brief. 1.05. What is the difference between the highest and the lowest Imports(as % of merchandise exports) of Middle income?
Ensure brevity in your answer.  6.25. What is the difference between the highest and the lowest Imports(as % of merchandise exports) of Chile?
Offer a very short reply. 5.17. What is the difference between the highest and the lowest Imports(as % of merchandise exports) in Israel?
Provide a short and direct response. 5.96. What is the difference between the highest and the lowest Imports(as % of merchandise exports) of Venezuela?
Keep it short and to the point. 7.07. 